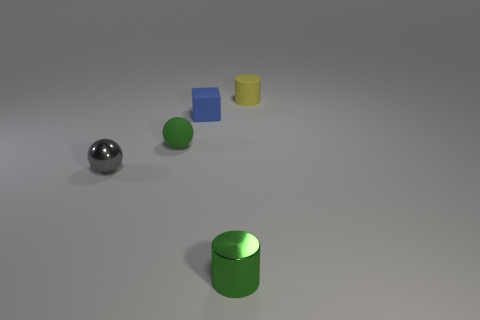What number of things are big yellow cylinders or yellow rubber cylinders?
Your answer should be very brief. 1. The blue block is what size?
Your response must be concise. Small. There is a thing that is right of the cube and in front of the blue matte object; what shape is it?
Offer a terse response. Cylinder. What is the color of the other object that is the same shape as the gray object?
Keep it short and to the point. Green. What number of things are either small green objects that are behind the gray metallic ball or matte objects in front of the tiny yellow cylinder?
Your answer should be compact. 2. What is the shape of the tiny gray thing?
Provide a short and direct response. Sphere. What shape is the rubber object that is the same color as the tiny metallic cylinder?
Make the answer very short. Sphere. What number of tiny cylinders have the same material as the blue thing?
Give a very brief answer. 1. The rubber ball is what color?
Ensure brevity in your answer.  Green. What is the color of the metallic ball that is the same size as the blue block?
Provide a short and direct response. Gray. 